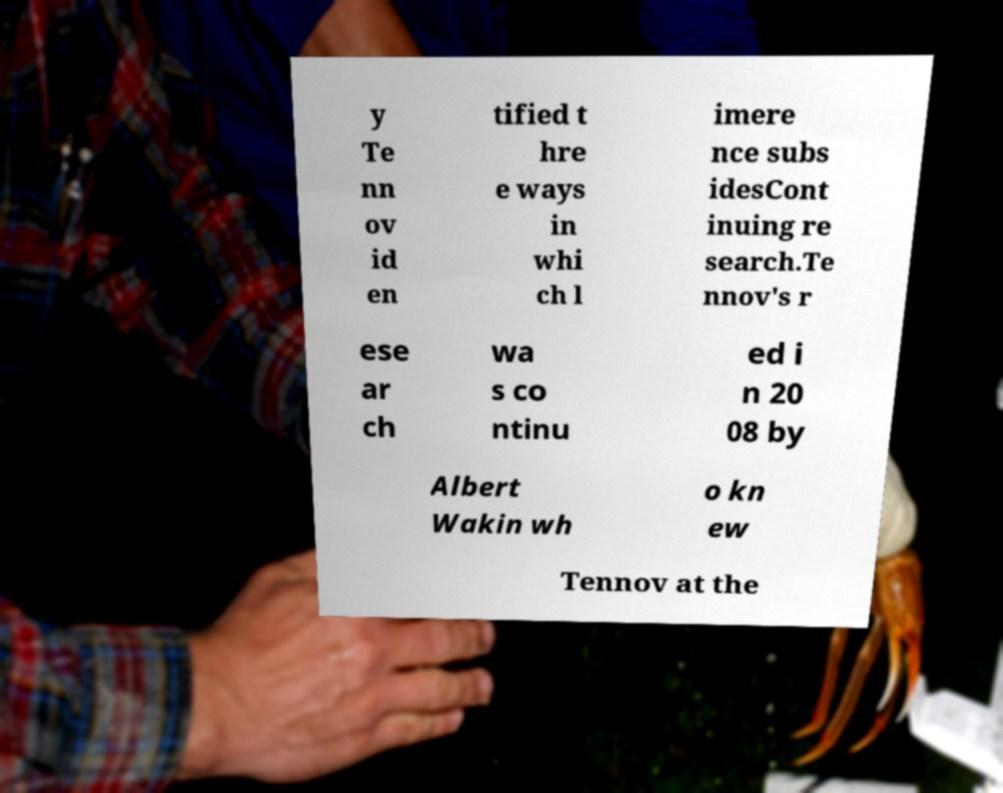There's text embedded in this image that I need extracted. Can you transcribe it verbatim? y Te nn ov id en tified t hre e ways in whi ch l imere nce subs idesCont inuing re search.Te nnov's r ese ar ch wa s co ntinu ed i n 20 08 by Albert Wakin wh o kn ew Tennov at the 